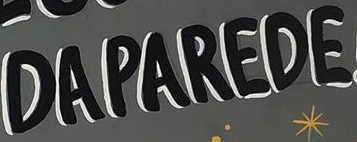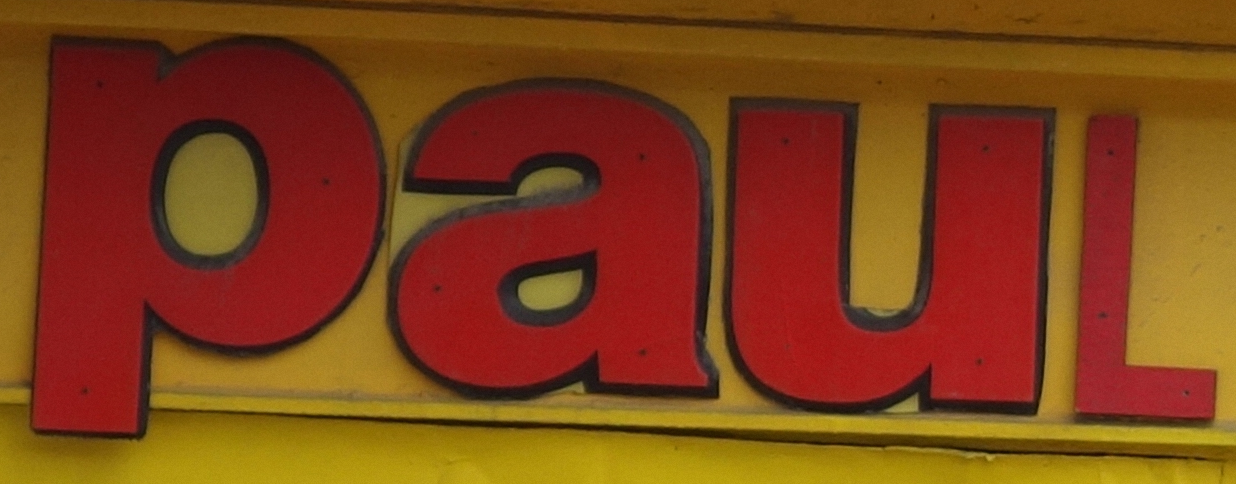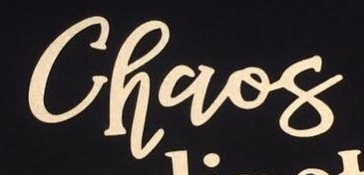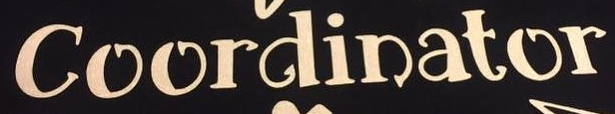Identify the words shown in these images in order, separated by a semicolon. DAPAREDE; PauL; Chaos; Coordinator 